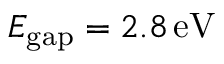<formula> <loc_0><loc_0><loc_500><loc_500>E _ { g a p } = 2 . 8 \, e V</formula> 